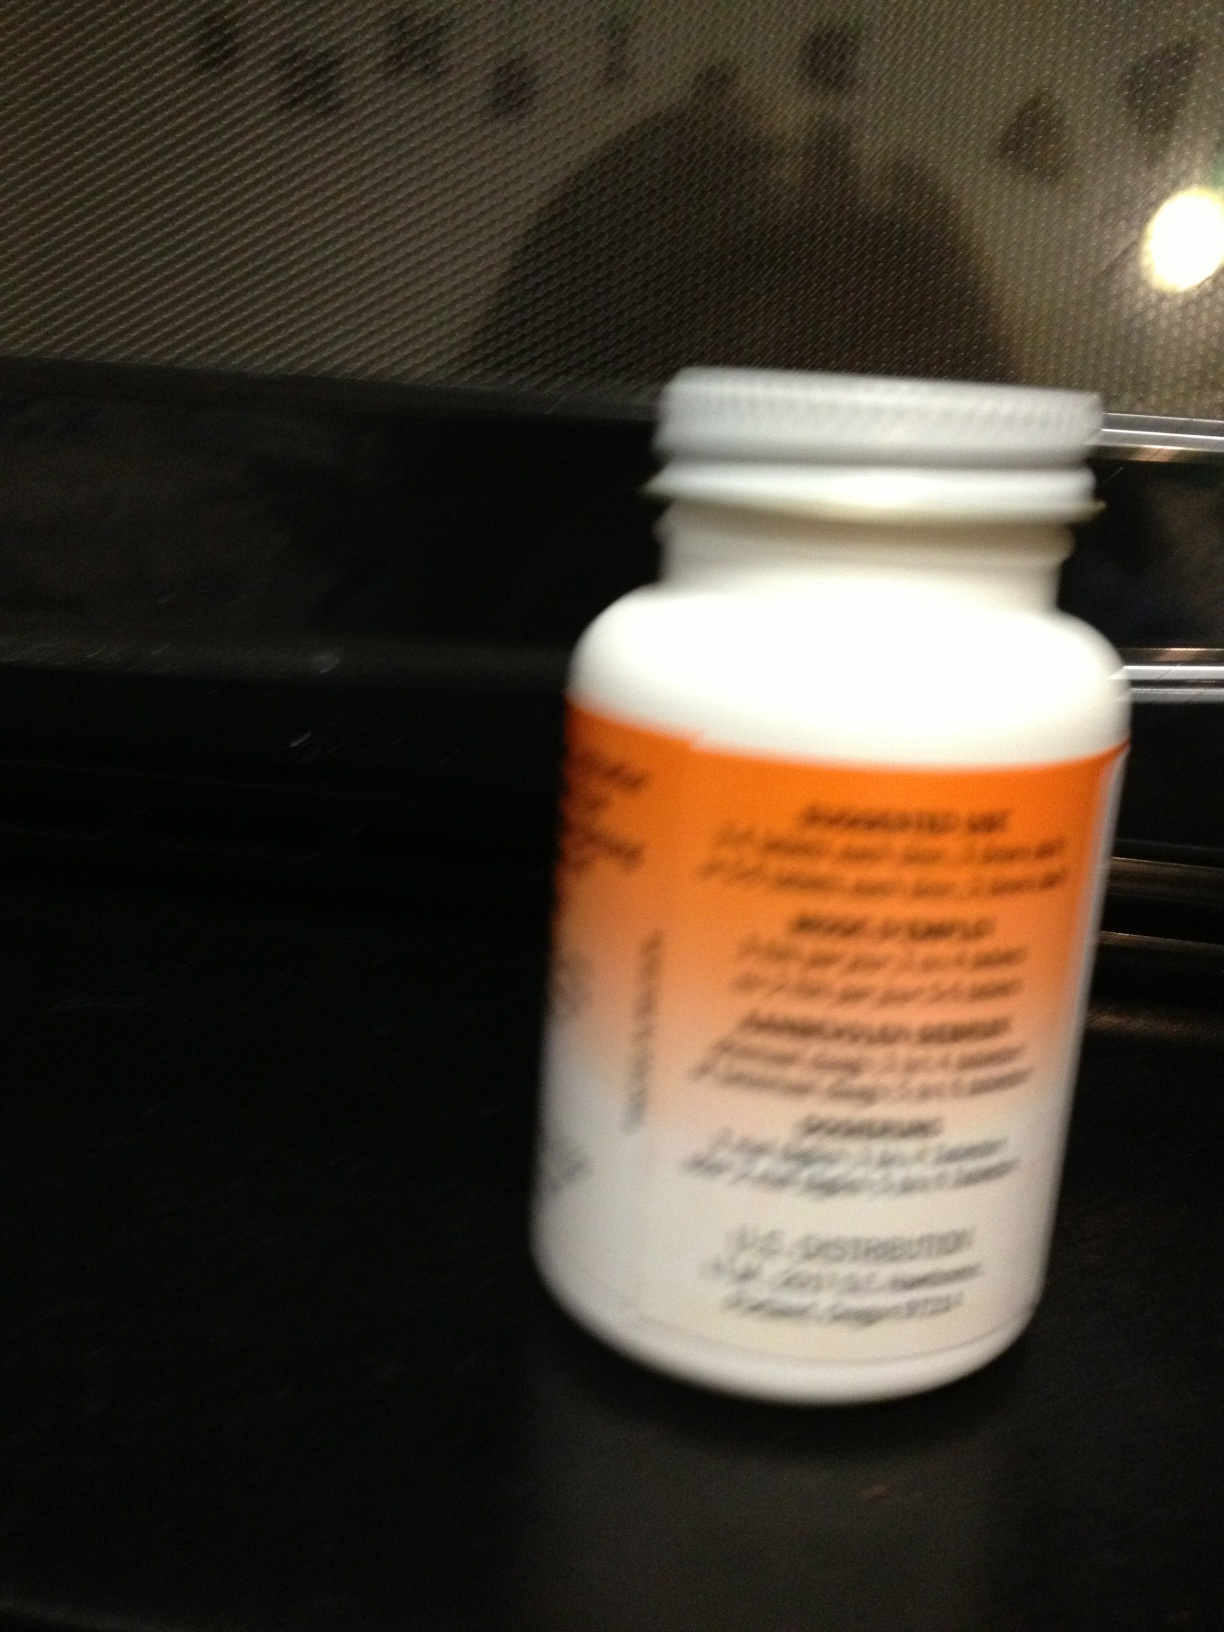Is there any information visible about storage instructions or warnings? The blurriness of the image makes it difficult to read specific text regarding storage instructions or warnings. However, most medication bottles like this include storage directions, like keeping the bottle away from extreme temperatures and out of reach of children, as well as any pertinent usage warnings. 